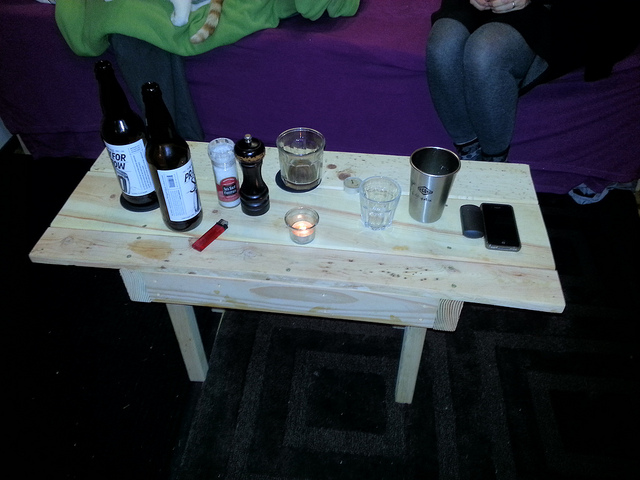What could be the occasion for the items arranged on this table? The items on the table, including several types of bottles, a thermos, and casual drinkware, hint at a social gathering. This could range from a small party, an informal meet-up among friends, or perhaps an after-work relaxation spot. The presence of candles and a smartphone suggests an intention to create a welcoming and intimate ambiance. 